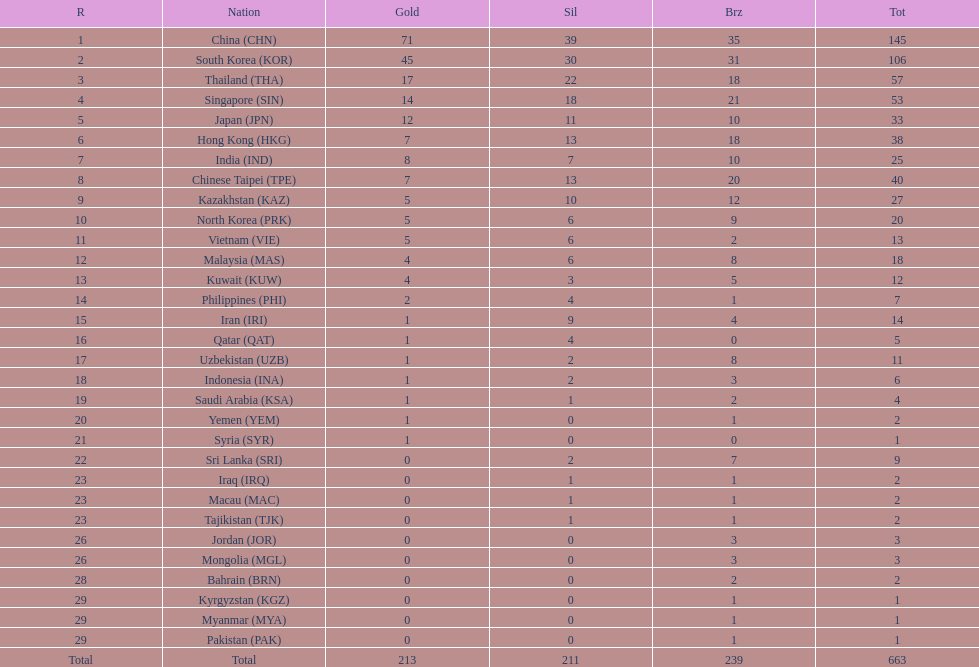How many more gold medals must qatar win before they can earn 12 gold medals? 11. 